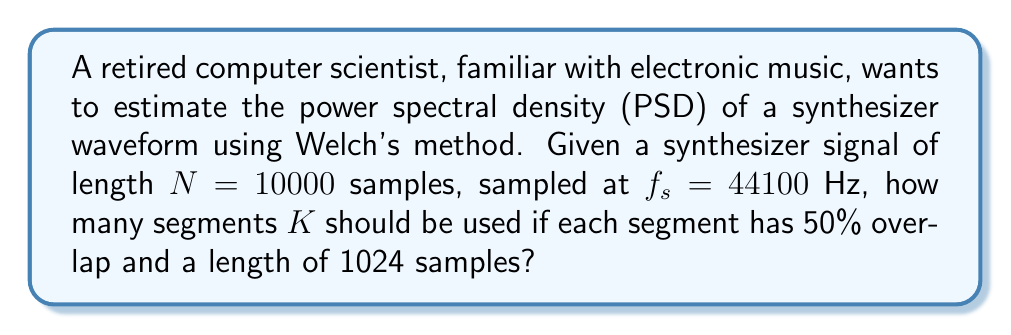Help me with this question. To estimate the number of segments $K$ in Welch's method with the given parameters, we follow these steps:

1. Define the variables:
   $N = 10000$ (total number of samples)
   $L = 1024$ (length of each segment)
   Overlap = 50% = 0.5

2. Calculate the number of non-overlapping samples per segment:
   $$ \text{Non-overlapping samples} = L \times (1 - \text{Overlap}) = 1024 \times (1 - 0.5) = 512 $$

3. Calculate the number of segments $K$:
   $$ K = \left\lfloor \frac{N - L}{L \times (1 - \text{Overlap})} + 1 \right\rfloor $$
   
   Where $\lfloor \cdot \rfloor$ denotes the floor function.

4. Substitute the values:
   $$ K = \left\lfloor \frac{10000 - 1024}{1024 \times (1 - 0.5)} + 1 \right\rfloor $$
   $$ K = \left\lfloor \frac{8976}{512} + 1 \right\rfloor $$
   $$ K = \left\lfloor 17.53125 + 1 \right\rfloor $$
   $$ K = \left\lfloor 18.53125 \right\rfloor = 18 $$

Therefore, 18 segments should be used in Welch's method for the given synthesizer signal.
Answer: 18 segments 